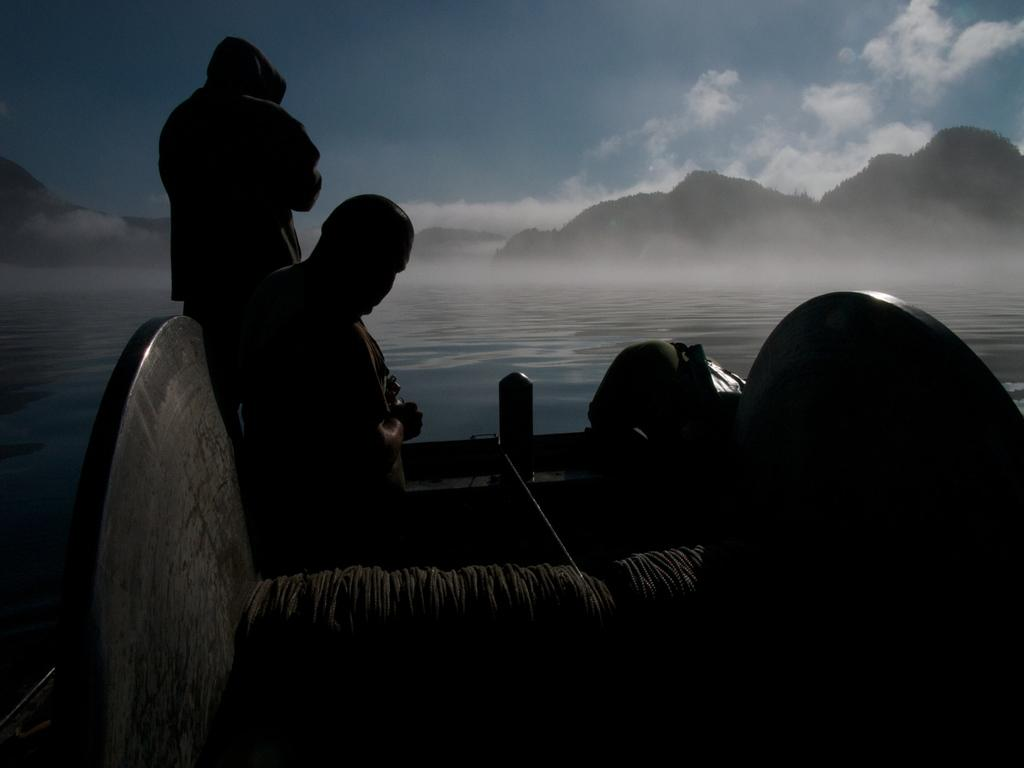How many people are in the foreground of the image? There are two men in the foreground of the image. What are the men doing in the image? The men are on a boat. What can be seen in the background of the image? There is water, mountains, and the sky visible in the background of the image. What is the condition of the sky in the image? The sky is visible in the background of the image, and there are clouds present. What type of stone is the mom holding in the image? There is no mom or stone present in the image. What territory is being claimed by the men in the image? There is no indication in the image that the men are claiming any territory. 